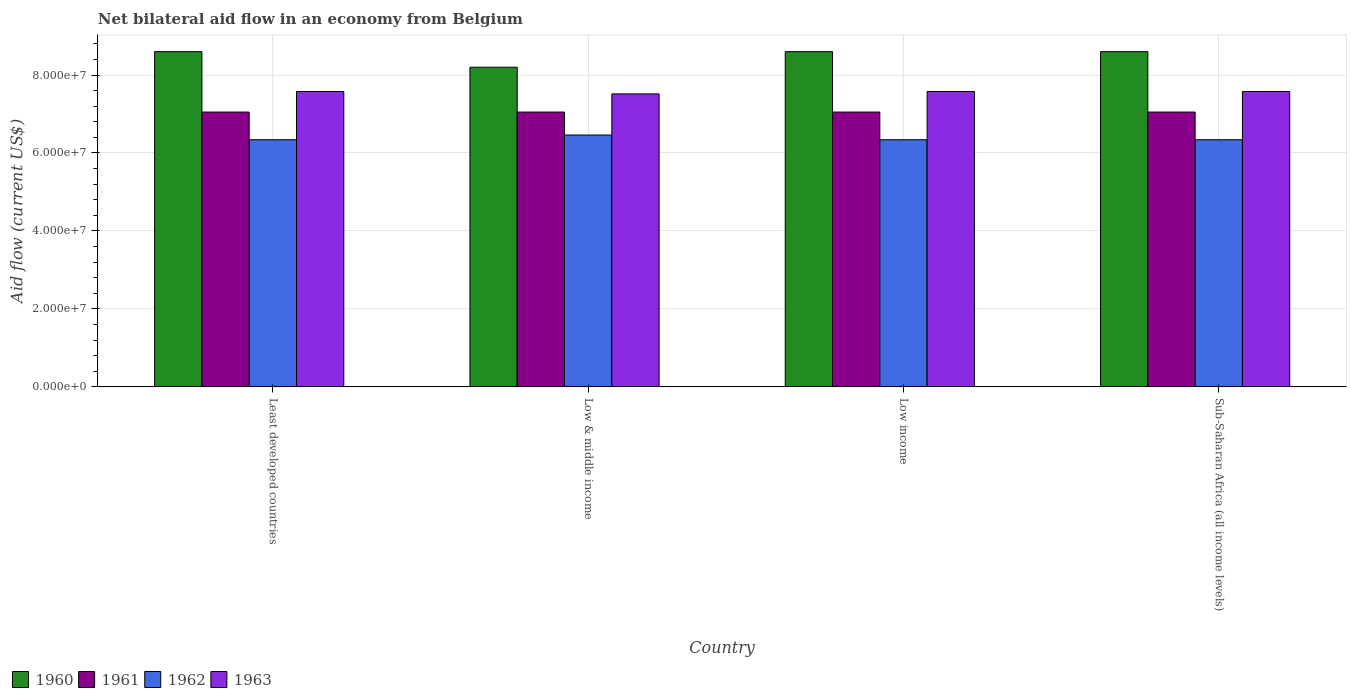How many different coloured bars are there?
Make the answer very short. 4. How many groups of bars are there?
Provide a succinct answer. 4. How many bars are there on the 2nd tick from the left?
Offer a terse response. 4. How many bars are there on the 2nd tick from the right?
Your response must be concise. 4. What is the label of the 3rd group of bars from the left?
Your answer should be compact. Low income. What is the net bilateral aid flow in 1962 in Low income?
Keep it short and to the point. 6.34e+07. Across all countries, what is the maximum net bilateral aid flow in 1961?
Provide a short and direct response. 7.05e+07. Across all countries, what is the minimum net bilateral aid flow in 1962?
Keep it short and to the point. 6.34e+07. In which country was the net bilateral aid flow in 1961 maximum?
Your answer should be very brief. Least developed countries. In which country was the net bilateral aid flow in 1960 minimum?
Your answer should be compact. Low & middle income. What is the total net bilateral aid flow in 1963 in the graph?
Keep it short and to the point. 3.02e+08. What is the difference between the net bilateral aid flow in 1961 in Least developed countries and that in Sub-Saharan Africa (all income levels)?
Offer a very short reply. 0. What is the difference between the net bilateral aid flow in 1963 in Sub-Saharan Africa (all income levels) and the net bilateral aid flow in 1961 in Low & middle income?
Offer a terse response. 5.27e+06. What is the average net bilateral aid flow in 1962 per country?
Offer a terse response. 6.37e+07. What is the difference between the net bilateral aid flow of/in 1960 and net bilateral aid flow of/in 1963 in Sub-Saharan Africa (all income levels)?
Make the answer very short. 1.02e+07. What is the ratio of the net bilateral aid flow in 1960 in Least developed countries to that in Low & middle income?
Ensure brevity in your answer.  1.05. What is the difference between the highest and the second highest net bilateral aid flow in 1962?
Provide a short and direct response. 1.21e+06. What is the difference between the highest and the lowest net bilateral aid flow in 1962?
Provide a succinct answer. 1.21e+06. In how many countries, is the net bilateral aid flow in 1960 greater than the average net bilateral aid flow in 1960 taken over all countries?
Offer a terse response. 3. Is it the case that in every country, the sum of the net bilateral aid flow in 1961 and net bilateral aid flow in 1963 is greater than the sum of net bilateral aid flow in 1960 and net bilateral aid flow in 1962?
Ensure brevity in your answer.  No. How many countries are there in the graph?
Your answer should be compact. 4. What is the difference between two consecutive major ticks on the Y-axis?
Provide a succinct answer. 2.00e+07. Are the values on the major ticks of Y-axis written in scientific E-notation?
Make the answer very short. Yes. Where does the legend appear in the graph?
Offer a very short reply. Bottom left. How are the legend labels stacked?
Offer a terse response. Horizontal. What is the title of the graph?
Keep it short and to the point. Net bilateral aid flow in an economy from Belgium. What is the label or title of the X-axis?
Make the answer very short. Country. What is the Aid flow (current US$) of 1960 in Least developed countries?
Offer a terse response. 8.60e+07. What is the Aid flow (current US$) of 1961 in Least developed countries?
Offer a very short reply. 7.05e+07. What is the Aid flow (current US$) of 1962 in Least developed countries?
Provide a succinct answer. 6.34e+07. What is the Aid flow (current US$) of 1963 in Least developed countries?
Your answer should be compact. 7.58e+07. What is the Aid flow (current US$) in 1960 in Low & middle income?
Offer a terse response. 8.20e+07. What is the Aid flow (current US$) of 1961 in Low & middle income?
Provide a succinct answer. 7.05e+07. What is the Aid flow (current US$) in 1962 in Low & middle income?
Offer a terse response. 6.46e+07. What is the Aid flow (current US$) of 1963 in Low & middle income?
Offer a very short reply. 7.52e+07. What is the Aid flow (current US$) of 1960 in Low income?
Your answer should be very brief. 8.60e+07. What is the Aid flow (current US$) of 1961 in Low income?
Keep it short and to the point. 7.05e+07. What is the Aid flow (current US$) in 1962 in Low income?
Your answer should be very brief. 6.34e+07. What is the Aid flow (current US$) of 1963 in Low income?
Ensure brevity in your answer.  7.58e+07. What is the Aid flow (current US$) in 1960 in Sub-Saharan Africa (all income levels)?
Offer a very short reply. 8.60e+07. What is the Aid flow (current US$) in 1961 in Sub-Saharan Africa (all income levels)?
Your answer should be very brief. 7.05e+07. What is the Aid flow (current US$) of 1962 in Sub-Saharan Africa (all income levels)?
Ensure brevity in your answer.  6.34e+07. What is the Aid flow (current US$) in 1963 in Sub-Saharan Africa (all income levels)?
Offer a very short reply. 7.58e+07. Across all countries, what is the maximum Aid flow (current US$) of 1960?
Your answer should be very brief. 8.60e+07. Across all countries, what is the maximum Aid flow (current US$) of 1961?
Ensure brevity in your answer.  7.05e+07. Across all countries, what is the maximum Aid flow (current US$) of 1962?
Keep it short and to the point. 6.46e+07. Across all countries, what is the maximum Aid flow (current US$) of 1963?
Your response must be concise. 7.58e+07. Across all countries, what is the minimum Aid flow (current US$) of 1960?
Your answer should be compact. 8.20e+07. Across all countries, what is the minimum Aid flow (current US$) of 1961?
Your answer should be compact. 7.05e+07. Across all countries, what is the minimum Aid flow (current US$) of 1962?
Your answer should be very brief. 6.34e+07. Across all countries, what is the minimum Aid flow (current US$) of 1963?
Offer a very short reply. 7.52e+07. What is the total Aid flow (current US$) in 1960 in the graph?
Your answer should be compact. 3.40e+08. What is the total Aid flow (current US$) of 1961 in the graph?
Provide a succinct answer. 2.82e+08. What is the total Aid flow (current US$) in 1962 in the graph?
Ensure brevity in your answer.  2.55e+08. What is the total Aid flow (current US$) of 1963 in the graph?
Your answer should be very brief. 3.02e+08. What is the difference between the Aid flow (current US$) of 1962 in Least developed countries and that in Low & middle income?
Offer a very short reply. -1.21e+06. What is the difference between the Aid flow (current US$) in 1963 in Least developed countries and that in Low & middle income?
Offer a very short reply. 6.10e+05. What is the difference between the Aid flow (current US$) in 1961 in Least developed countries and that in Low income?
Your answer should be very brief. 0. What is the difference between the Aid flow (current US$) in 1963 in Least developed countries and that in Low income?
Give a very brief answer. 0. What is the difference between the Aid flow (current US$) in 1960 in Least developed countries and that in Sub-Saharan Africa (all income levels)?
Make the answer very short. 0. What is the difference between the Aid flow (current US$) in 1960 in Low & middle income and that in Low income?
Make the answer very short. -4.00e+06. What is the difference between the Aid flow (current US$) of 1961 in Low & middle income and that in Low income?
Ensure brevity in your answer.  0. What is the difference between the Aid flow (current US$) of 1962 in Low & middle income and that in Low income?
Your answer should be very brief. 1.21e+06. What is the difference between the Aid flow (current US$) in 1963 in Low & middle income and that in Low income?
Your answer should be very brief. -6.10e+05. What is the difference between the Aid flow (current US$) in 1961 in Low & middle income and that in Sub-Saharan Africa (all income levels)?
Provide a short and direct response. 0. What is the difference between the Aid flow (current US$) in 1962 in Low & middle income and that in Sub-Saharan Africa (all income levels)?
Your answer should be very brief. 1.21e+06. What is the difference between the Aid flow (current US$) of 1963 in Low & middle income and that in Sub-Saharan Africa (all income levels)?
Provide a short and direct response. -6.10e+05. What is the difference between the Aid flow (current US$) in 1960 in Low income and that in Sub-Saharan Africa (all income levels)?
Provide a short and direct response. 0. What is the difference between the Aid flow (current US$) in 1963 in Low income and that in Sub-Saharan Africa (all income levels)?
Provide a short and direct response. 0. What is the difference between the Aid flow (current US$) in 1960 in Least developed countries and the Aid flow (current US$) in 1961 in Low & middle income?
Your response must be concise. 1.55e+07. What is the difference between the Aid flow (current US$) in 1960 in Least developed countries and the Aid flow (current US$) in 1962 in Low & middle income?
Ensure brevity in your answer.  2.14e+07. What is the difference between the Aid flow (current US$) in 1960 in Least developed countries and the Aid flow (current US$) in 1963 in Low & middle income?
Keep it short and to the point. 1.08e+07. What is the difference between the Aid flow (current US$) in 1961 in Least developed countries and the Aid flow (current US$) in 1962 in Low & middle income?
Make the answer very short. 5.89e+06. What is the difference between the Aid flow (current US$) of 1961 in Least developed countries and the Aid flow (current US$) of 1963 in Low & middle income?
Make the answer very short. -4.66e+06. What is the difference between the Aid flow (current US$) of 1962 in Least developed countries and the Aid flow (current US$) of 1963 in Low & middle income?
Offer a terse response. -1.18e+07. What is the difference between the Aid flow (current US$) in 1960 in Least developed countries and the Aid flow (current US$) in 1961 in Low income?
Your response must be concise. 1.55e+07. What is the difference between the Aid flow (current US$) in 1960 in Least developed countries and the Aid flow (current US$) in 1962 in Low income?
Keep it short and to the point. 2.26e+07. What is the difference between the Aid flow (current US$) of 1960 in Least developed countries and the Aid flow (current US$) of 1963 in Low income?
Offer a very short reply. 1.02e+07. What is the difference between the Aid flow (current US$) of 1961 in Least developed countries and the Aid flow (current US$) of 1962 in Low income?
Keep it short and to the point. 7.10e+06. What is the difference between the Aid flow (current US$) in 1961 in Least developed countries and the Aid flow (current US$) in 1963 in Low income?
Ensure brevity in your answer.  -5.27e+06. What is the difference between the Aid flow (current US$) of 1962 in Least developed countries and the Aid flow (current US$) of 1963 in Low income?
Offer a terse response. -1.24e+07. What is the difference between the Aid flow (current US$) in 1960 in Least developed countries and the Aid flow (current US$) in 1961 in Sub-Saharan Africa (all income levels)?
Provide a succinct answer. 1.55e+07. What is the difference between the Aid flow (current US$) in 1960 in Least developed countries and the Aid flow (current US$) in 1962 in Sub-Saharan Africa (all income levels)?
Ensure brevity in your answer.  2.26e+07. What is the difference between the Aid flow (current US$) of 1960 in Least developed countries and the Aid flow (current US$) of 1963 in Sub-Saharan Africa (all income levels)?
Offer a terse response. 1.02e+07. What is the difference between the Aid flow (current US$) in 1961 in Least developed countries and the Aid flow (current US$) in 1962 in Sub-Saharan Africa (all income levels)?
Your response must be concise. 7.10e+06. What is the difference between the Aid flow (current US$) in 1961 in Least developed countries and the Aid flow (current US$) in 1963 in Sub-Saharan Africa (all income levels)?
Your answer should be very brief. -5.27e+06. What is the difference between the Aid flow (current US$) of 1962 in Least developed countries and the Aid flow (current US$) of 1963 in Sub-Saharan Africa (all income levels)?
Ensure brevity in your answer.  -1.24e+07. What is the difference between the Aid flow (current US$) in 1960 in Low & middle income and the Aid flow (current US$) in 1961 in Low income?
Keep it short and to the point. 1.15e+07. What is the difference between the Aid flow (current US$) of 1960 in Low & middle income and the Aid flow (current US$) of 1962 in Low income?
Provide a succinct answer. 1.86e+07. What is the difference between the Aid flow (current US$) of 1960 in Low & middle income and the Aid flow (current US$) of 1963 in Low income?
Offer a terse response. 6.23e+06. What is the difference between the Aid flow (current US$) of 1961 in Low & middle income and the Aid flow (current US$) of 1962 in Low income?
Your response must be concise. 7.10e+06. What is the difference between the Aid flow (current US$) of 1961 in Low & middle income and the Aid flow (current US$) of 1963 in Low income?
Ensure brevity in your answer.  -5.27e+06. What is the difference between the Aid flow (current US$) in 1962 in Low & middle income and the Aid flow (current US$) in 1963 in Low income?
Make the answer very short. -1.12e+07. What is the difference between the Aid flow (current US$) in 1960 in Low & middle income and the Aid flow (current US$) in 1961 in Sub-Saharan Africa (all income levels)?
Keep it short and to the point. 1.15e+07. What is the difference between the Aid flow (current US$) of 1960 in Low & middle income and the Aid flow (current US$) of 1962 in Sub-Saharan Africa (all income levels)?
Make the answer very short. 1.86e+07. What is the difference between the Aid flow (current US$) in 1960 in Low & middle income and the Aid flow (current US$) in 1963 in Sub-Saharan Africa (all income levels)?
Make the answer very short. 6.23e+06. What is the difference between the Aid flow (current US$) in 1961 in Low & middle income and the Aid flow (current US$) in 1962 in Sub-Saharan Africa (all income levels)?
Provide a succinct answer. 7.10e+06. What is the difference between the Aid flow (current US$) in 1961 in Low & middle income and the Aid flow (current US$) in 1963 in Sub-Saharan Africa (all income levels)?
Provide a short and direct response. -5.27e+06. What is the difference between the Aid flow (current US$) of 1962 in Low & middle income and the Aid flow (current US$) of 1963 in Sub-Saharan Africa (all income levels)?
Provide a succinct answer. -1.12e+07. What is the difference between the Aid flow (current US$) in 1960 in Low income and the Aid flow (current US$) in 1961 in Sub-Saharan Africa (all income levels)?
Your answer should be very brief. 1.55e+07. What is the difference between the Aid flow (current US$) in 1960 in Low income and the Aid flow (current US$) in 1962 in Sub-Saharan Africa (all income levels)?
Offer a very short reply. 2.26e+07. What is the difference between the Aid flow (current US$) in 1960 in Low income and the Aid flow (current US$) in 1963 in Sub-Saharan Africa (all income levels)?
Provide a short and direct response. 1.02e+07. What is the difference between the Aid flow (current US$) in 1961 in Low income and the Aid flow (current US$) in 1962 in Sub-Saharan Africa (all income levels)?
Keep it short and to the point. 7.10e+06. What is the difference between the Aid flow (current US$) in 1961 in Low income and the Aid flow (current US$) in 1963 in Sub-Saharan Africa (all income levels)?
Offer a very short reply. -5.27e+06. What is the difference between the Aid flow (current US$) of 1962 in Low income and the Aid flow (current US$) of 1963 in Sub-Saharan Africa (all income levels)?
Offer a very short reply. -1.24e+07. What is the average Aid flow (current US$) in 1960 per country?
Make the answer very short. 8.50e+07. What is the average Aid flow (current US$) of 1961 per country?
Keep it short and to the point. 7.05e+07. What is the average Aid flow (current US$) in 1962 per country?
Your answer should be compact. 6.37e+07. What is the average Aid flow (current US$) in 1963 per country?
Your answer should be compact. 7.56e+07. What is the difference between the Aid flow (current US$) of 1960 and Aid flow (current US$) of 1961 in Least developed countries?
Your response must be concise. 1.55e+07. What is the difference between the Aid flow (current US$) of 1960 and Aid flow (current US$) of 1962 in Least developed countries?
Provide a succinct answer. 2.26e+07. What is the difference between the Aid flow (current US$) in 1960 and Aid flow (current US$) in 1963 in Least developed countries?
Offer a very short reply. 1.02e+07. What is the difference between the Aid flow (current US$) of 1961 and Aid flow (current US$) of 1962 in Least developed countries?
Your answer should be very brief. 7.10e+06. What is the difference between the Aid flow (current US$) in 1961 and Aid flow (current US$) in 1963 in Least developed countries?
Your answer should be compact. -5.27e+06. What is the difference between the Aid flow (current US$) of 1962 and Aid flow (current US$) of 1963 in Least developed countries?
Your response must be concise. -1.24e+07. What is the difference between the Aid flow (current US$) in 1960 and Aid flow (current US$) in 1961 in Low & middle income?
Your answer should be compact. 1.15e+07. What is the difference between the Aid flow (current US$) of 1960 and Aid flow (current US$) of 1962 in Low & middle income?
Keep it short and to the point. 1.74e+07. What is the difference between the Aid flow (current US$) in 1960 and Aid flow (current US$) in 1963 in Low & middle income?
Offer a terse response. 6.84e+06. What is the difference between the Aid flow (current US$) in 1961 and Aid flow (current US$) in 1962 in Low & middle income?
Offer a terse response. 5.89e+06. What is the difference between the Aid flow (current US$) of 1961 and Aid flow (current US$) of 1963 in Low & middle income?
Provide a short and direct response. -4.66e+06. What is the difference between the Aid flow (current US$) in 1962 and Aid flow (current US$) in 1963 in Low & middle income?
Give a very brief answer. -1.06e+07. What is the difference between the Aid flow (current US$) in 1960 and Aid flow (current US$) in 1961 in Low income?
Provide a succinct answer. 1.55e+07. What is the difference between the Aid flow (current US$) of 1960 and Aid flow (current US$) of 1962 in Low income?
Provide a succinct answer. 2.26e+07. What is the difference between the Aid flow (current US$) of 1960 and Aid flow (current US$) of 1963 in Low income?
Offer a terse response. 1.02e+07. What is the difference between the Aid flow (current US$) in 1961 and Aid flow (current US$) in 1962 in Low income?
Offer a very short reply. 7.10e+06. What is the difference between the Aid flow (current US$) of 1961 and Aid flow (current US$) of 1963 in Low income?
Offer a terse response. -5.27e+06. What is the difference between the Aid flow (current US$) in 1962 and Aid flow (current US$) in 1963 in Low income?
Give a very brief answer. -1.24e+07. What is the difference between the Aid flow (current US$) in 1960 and Aid flow (current US$) in 1961 in Sub-Saharan Africa (all income levels)?
Provide a short and direct response. 1.55e+07. What is the difference between the Aid flow (current US$) of 1960 and Aid flow (current US$) of 1962 in Sub-Saharan Africa (all income levels)?
Ensure brevity in your answer.  2.26e+07. What is the difference between the Aid flow (current US$) of 1960 and Aid flow (current US$) of 1963 in Sub-Saharan Africa (all income levels)?
Offer a terse response. 1.02e+07. What is the difference between the Aid flow (current US$) in 1961 and Aid flow (current US$) in 1962 in Sub-Saharan Africa (all income levels)?
Give a very brief answer. 7.10e+06. What is the difference between the Aid flow (current US$) of 1961 and Aid flow (current US$) of 1963 in Sub-Saharan Africa (all income levels)?
Provide a succinct answer. -5.27e+06. What is the difference between the Aid flow (current US$) in 1962 and Aid flow (current US$) in 1963 in Sub-Saharan Africa (all income levels)?
Provide a succinct answer. -1.24e+07. What is the ratio of the Aid flow (current US$) of 1960 in Least developed countries to that in Low & middle income?
Give a very brief answer. 1.05. What is the ratio of the Aid flow (current US$) of 1962 in Least developed countries to that in Low & middle income?
Ensure brevity in your answer.  0.98. What is the ratio of the Aid flow (current US$) in 1960 in Least developed countries to that in Low income?
Give a very brief answer. 1. What is the ratio of the Aid flow (current US$) of 1961 in Least developed countries to that in Low income?
Offer a terse response. 1. What is the ratio of the Aid flow (current US$) of 1963 in Least developed countries to that in Low income?
Offer a terse response. 1. What is the ratio of the Aid flow (current US$) of 1960 in Least developed countries to that in Sub-Saharan Africa (all income levels)?
Make the answer very short. 1. What is the ratio of the Aid flow (current US$) in 1963 in Least developed countries to that in Sub-Saharan Africa (all income levels)?
Provide a succinct answer. 1. What is the ratio of the Aid flow (current US$) in 1960 in Low & middle income to that in Low income?
Make the answer very short. 0.95. What is the ratio of the Aid flow (current US$) of 1962 in Low & middle income to that in Low income?
Your response must be concise. 1.02. What is the ratio of the Aid flow (current US$) in 1960 in Low & middle income to that in Sub-Saharan Africa (all income levels)?
Give a very brief answer. 0.95. What is the ratio of the Aid flow (current US$) of 1961 in Low & middle income to that in Sub-Saharan Africa (all income levels)?
Ensure brevity in your answer.  1. What is the ratio of the Aid flow (current US$) of 1962 in Low & middle income to that in Sub-Saharan Africa (all income levels)?
Offer a terse response. 1.02. What is the ratio of the Aid flow (current US$) in 1961 in Low income to that in Sub-Saharan Africa (all income levels)?
Ensure brevity in your answer.  1. What is the difference between the highest and the second highest Aid flow (current US$) of 1961?
Your answer should be very brief. 0. What is the difference between the highest and the second highest Aid flow (current US$) in 1962?
Your answer should be very brief. 1.21e+06. What is the difference between the highest and the lowest Aid flow (current US$) of 1961?
Offer a terse response. 0. What is the difference between the highest and the lowest Aid flow (current US$) in 1962?
Your answer should be very brief. 1.21e+06. What is the difference between the highest and the lowest Aid flow (current US$) in 1963?
Your response must be concise. 6.10e+05. 